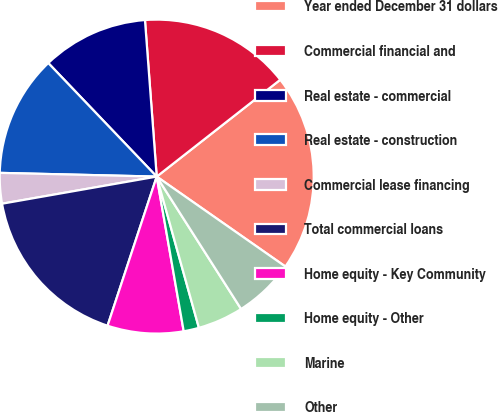<chart> <loc_0><loc_0><loc_500><loc_500><pie_chart><fcel>Year ended December 31 dollars<fcel>Commercial financial and<fcel>Real estate - commercial<fcel>Real estate - construction<fcel>Commercial lease financing<fcel>Total commercial loans<fcel>Home equity - Key Community<fcel>Home equity - Other<fcel>Marine<fcel>Other<nl><fcel>20.29%<fcel>15.61%<fcel>10.94%<fcel>12.49%<fcel>3.14%<fcel>17.17%<fcel>7.82%<fcel>1.58%<fcel>4.7%<fcel>6.26%<nl></chart> 